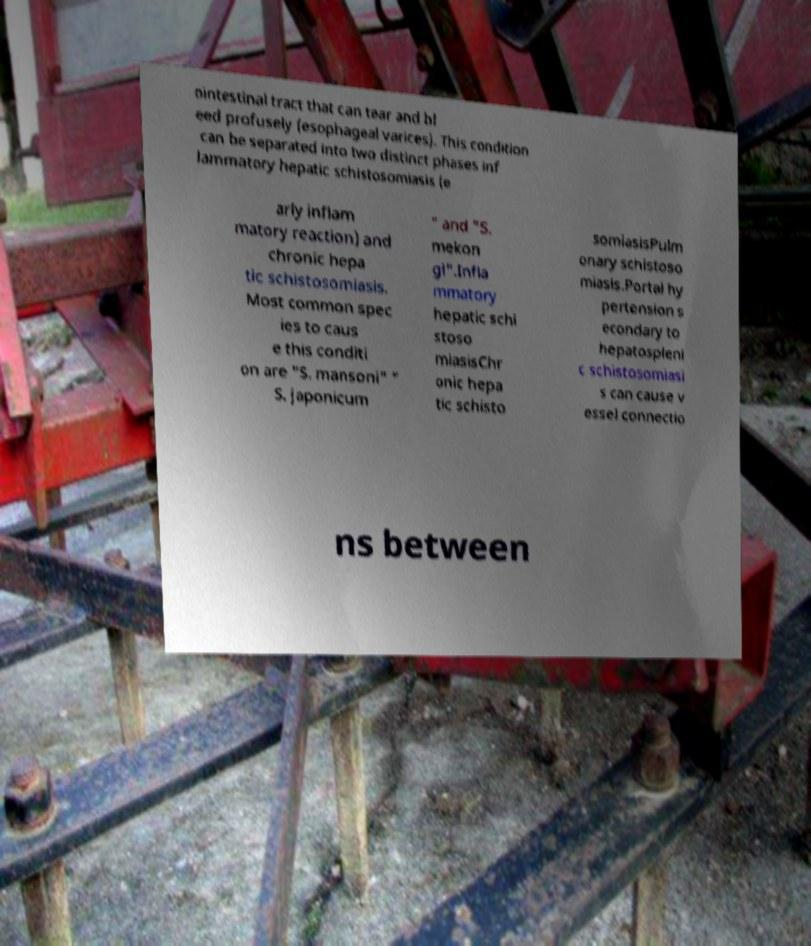Could you assist in decoding the text presented in this image and type it out clearly? ointestinal tract that can tear and bl eed profusely (esophageal varices). This condition can be separated into two distinct phases inf lammatory hepatic schistosomiasis (e arly inflam matory reaction) and chronic hepa tic schistosomiasis. Most common spec ies to caus e this conditi on are "S. mansoni" " S. japonicum " and "S. mekon gi".Infla mmatory hepatic schi stoso miasisChr onic hepa tic schisto somiasisPulm onary schistoso miasis.Portal hy pertension s econdary to hepatospleni c schistosomiasi s can cause v essel connectio ns between 